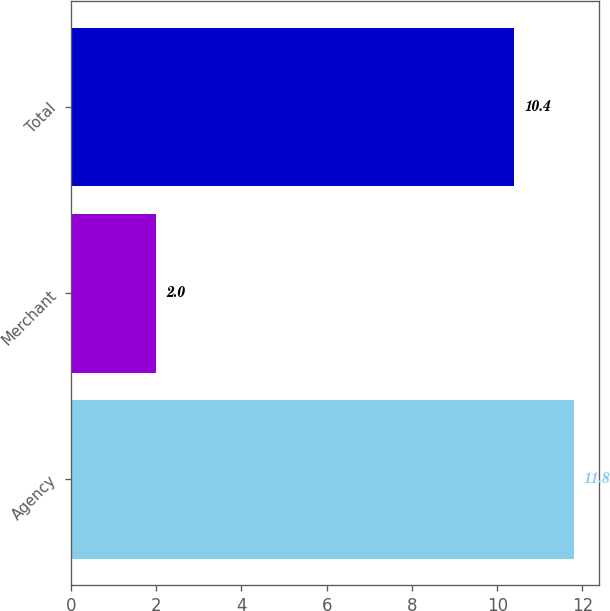<chart> <loc_0><loc_0><loc_500><loc_500><bar_chart><fcel>Agency<fcel>Merchant<fcel>Total<nl><fcel>11.8<fcel>2<fcel>10.4<nl></chart> 